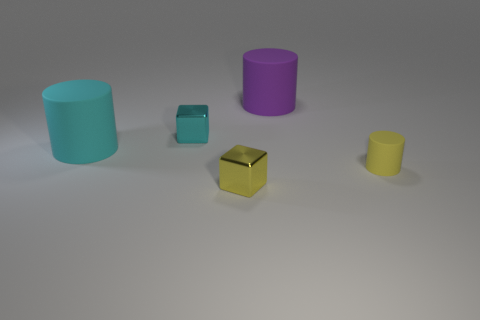Add 2 large blue matte balls. How many objects exist? 7 Subtract all blocks. How many objects are left? 3 Add 2 small blocks. How many small blocks are left? 4 Add 5 small cylinders. How many small cylinders exist? 6 Subtract 0 yellow spheres. How many objects are left? 5 Subtract all big cyan matte things. Subtract all tiny shiny things. How many objects are left? 2 